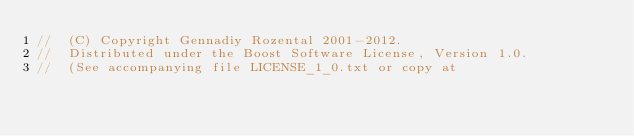<code> <loc_0><loc_0><loc_500><loc_500><_C++_>//  (C) Copyright Gennadiy Rozental 2001-2012.
//  Distributed under the Boost Software License, Version 1.0.
//  (See accompanying file LICENSE_1_0.txt or copy at </code> 